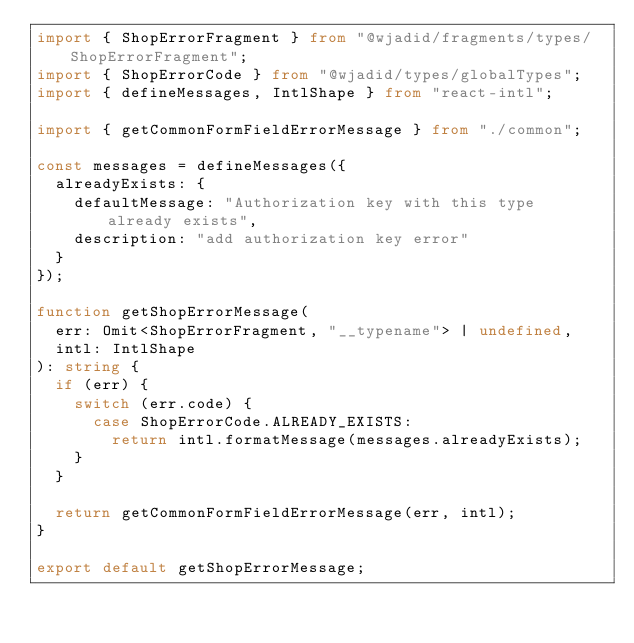Convert code to text. <code><loc_0><loc_0><loc_500><loc_500><_TypeScript_>import { ShopErrorFragment } from "@wjadid/fragments/types/ShopErrorFragment";
import { ShopErrorCode } from "@wjadid/types/globalTypes";
import { defineMessages, IntlShape } from "react-intl";

import { getCommonFormFieldErrorMessage } from "./common";

const messages = defineMessages({
  alreadyExists: {
    defaultMessage: "Authorization key with this type already exists",
    description: "add authorization key error"
  }
});

function getShopErrorMessage(
  err: Omit<ShopErrorFragment, "__typename"> | undefined,
  intl: IntlShape
): string {
  if (err) {
    switch (err.code) {
      case ShopErrorCode.ALREADY_EXISTS:
        return intl.formatMessage(messages.alreadyExists);
    }
  }

  return getCommonFormFieldErrorMessage(err, intl);
}

export default getShopErrorMessage;
</code> 